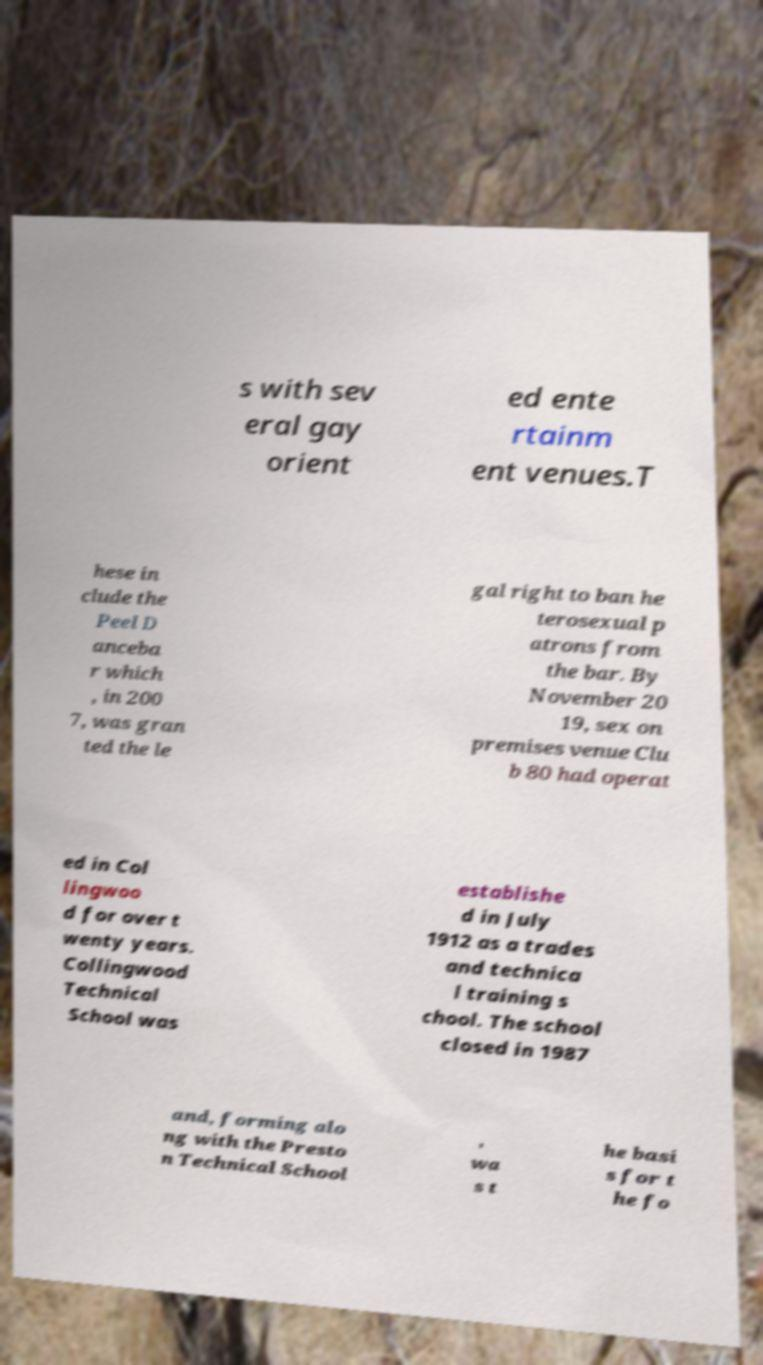There's text embedded in this image that I need extracted. Can you transcribe it verbatim? s with sev eral gay orient ed ente rtainm ent venues.T hese in clude the Peel D anceba r which , in 200 7, was gran ted the le gal right to ban he terosexual p atrons from the bar. By November 20 19, sex on premises venue Clu b 80 had operat ed in Col lingwoo d for over t wenty years. Collingwood Technical School was establishe d in July 1912 as a trades and technica l training s chool. The school closed in 1987 and, forming alo ng with the Presto n Technical School , wa s t he basi s for t he fo 